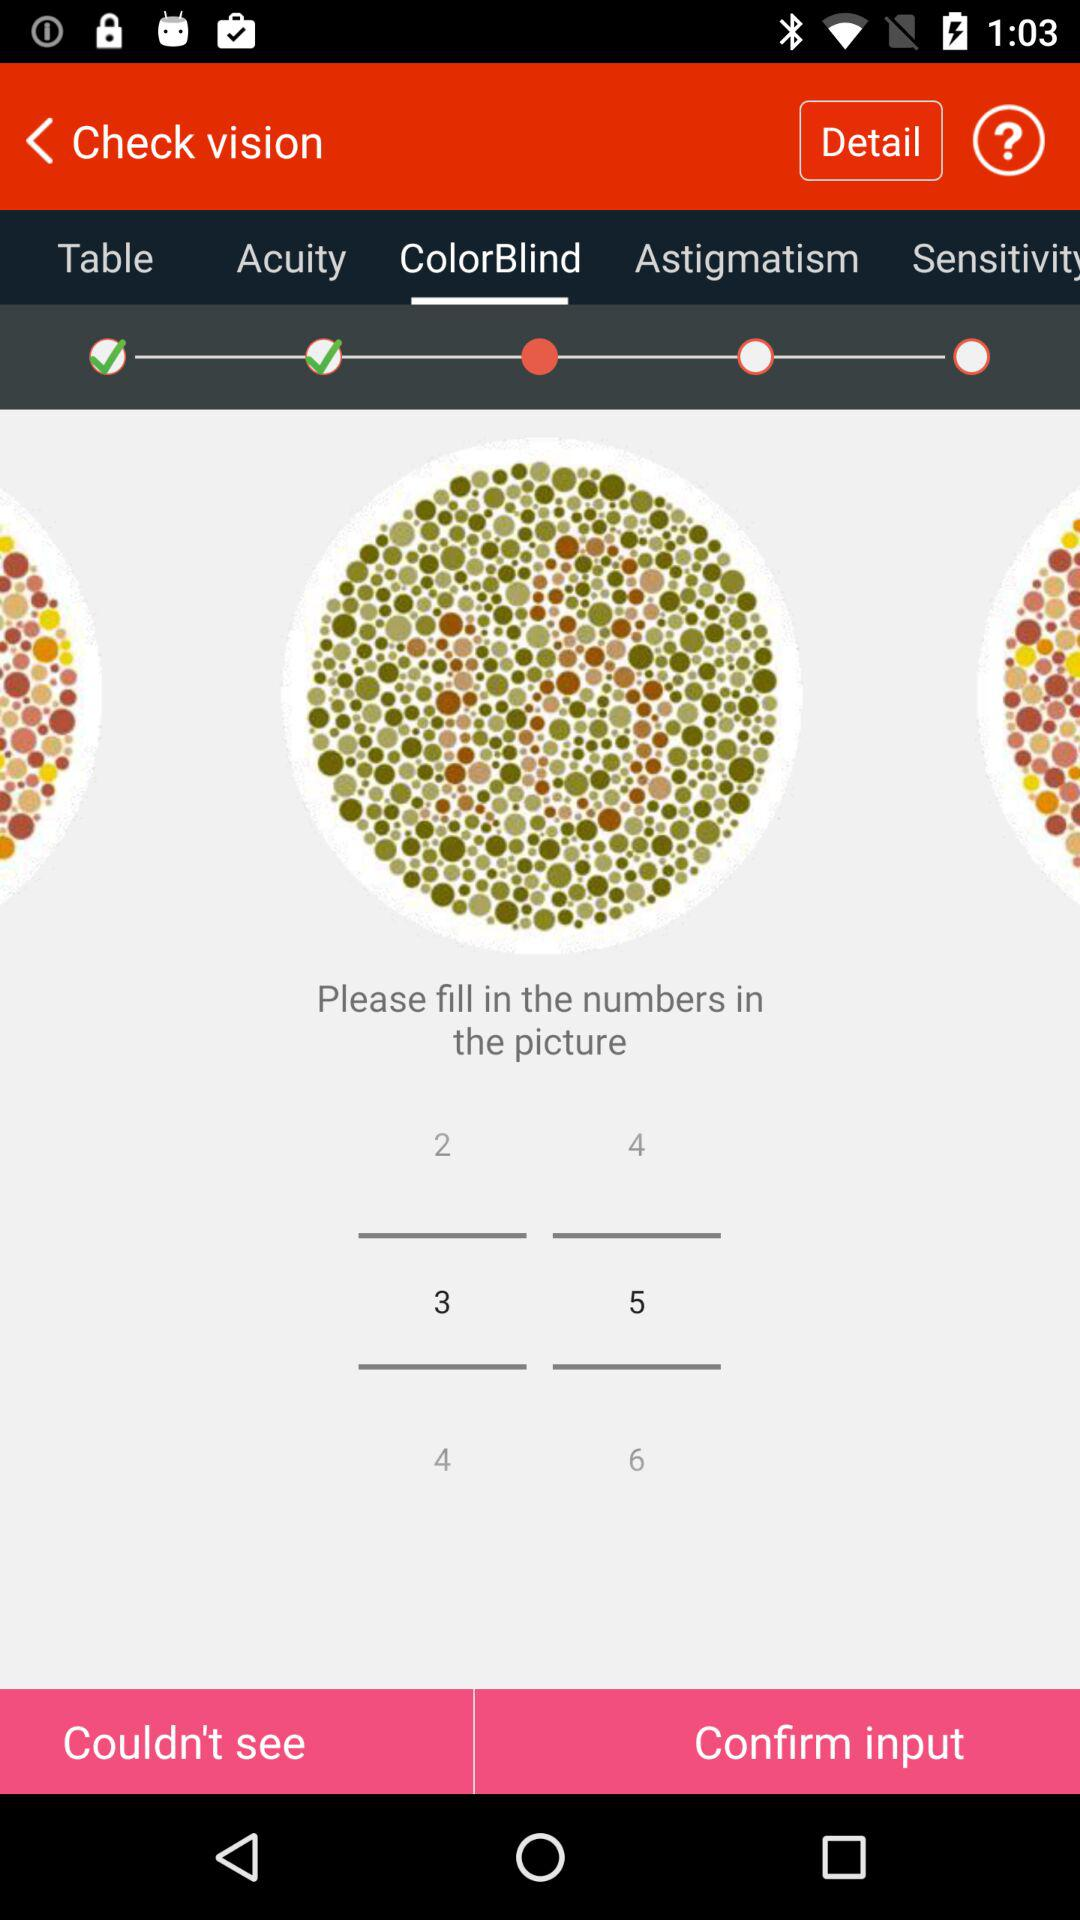What are the filled numbers? The filled numbers are 3 and 5. 